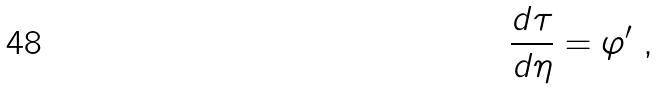<formula> <loc_0><loc_0><loc_500><loc_500>\frac { d \tau } { d \eta } = \varphi ^ { \prime } \ ,</formula> 